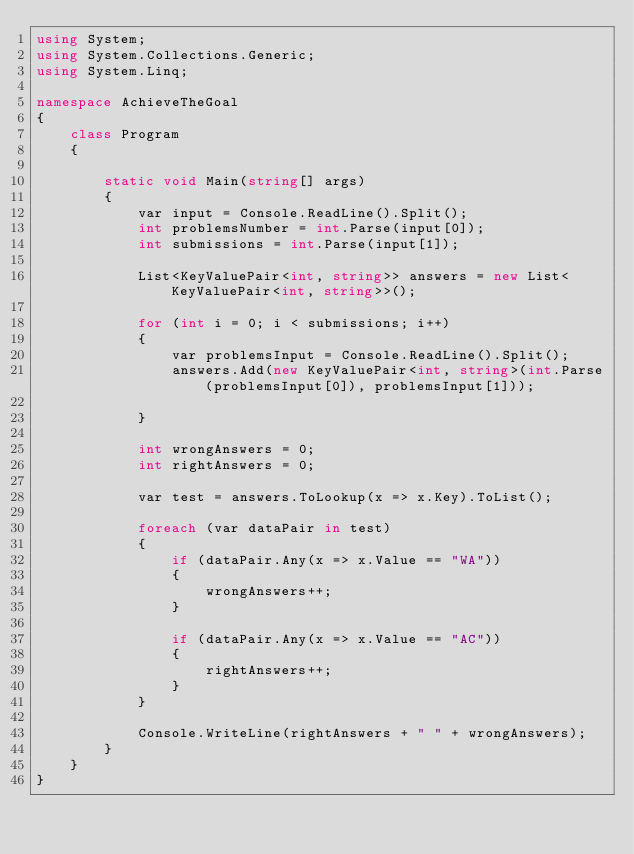<code> <loc_0><loc_0><loc_500><loc_500><_C#_>using System;
using System.Collections.Generic;
using System.Linq;

namespace AchieveTheGoal
{
    class Program
    {

        static void Main(string[] args)
        {
            var input = Console.ReadLine().Split();
            int problemsNumber = int.Parse(input[0]);
            int submissions = int.Parse(input[1]);

            List<KeyValuePair<int, string>> answers = new List<KeyValuePair<int, string>>();

            for (int i = 0; i < submissions; i++)
            {
                var problemsInput = Console.ReadLine().Split();
                answers.Add(new KeyValuePair<int, string>(int.Parse(problemsInput[0]), problemsInput[1]));

            }
            
            int wrongAnswers = 0;
            int rightAnswers = 0;

            var test = answers.ToLookup(x => x.Key).ToList();

            foreach (var dataPair in test)
            {
                if (dataPair.Any(x => x.Value == "WA"))
                {
                    wrongAnswers++;
                }

                if (dataPair.Any(x => x.Value == "AC"))
                {
                    rightAnswers++;                    
                }
            }

            Console.WriteLine(rightAnswers + " " + wrongAnswers);
        }
    }
}</code> 